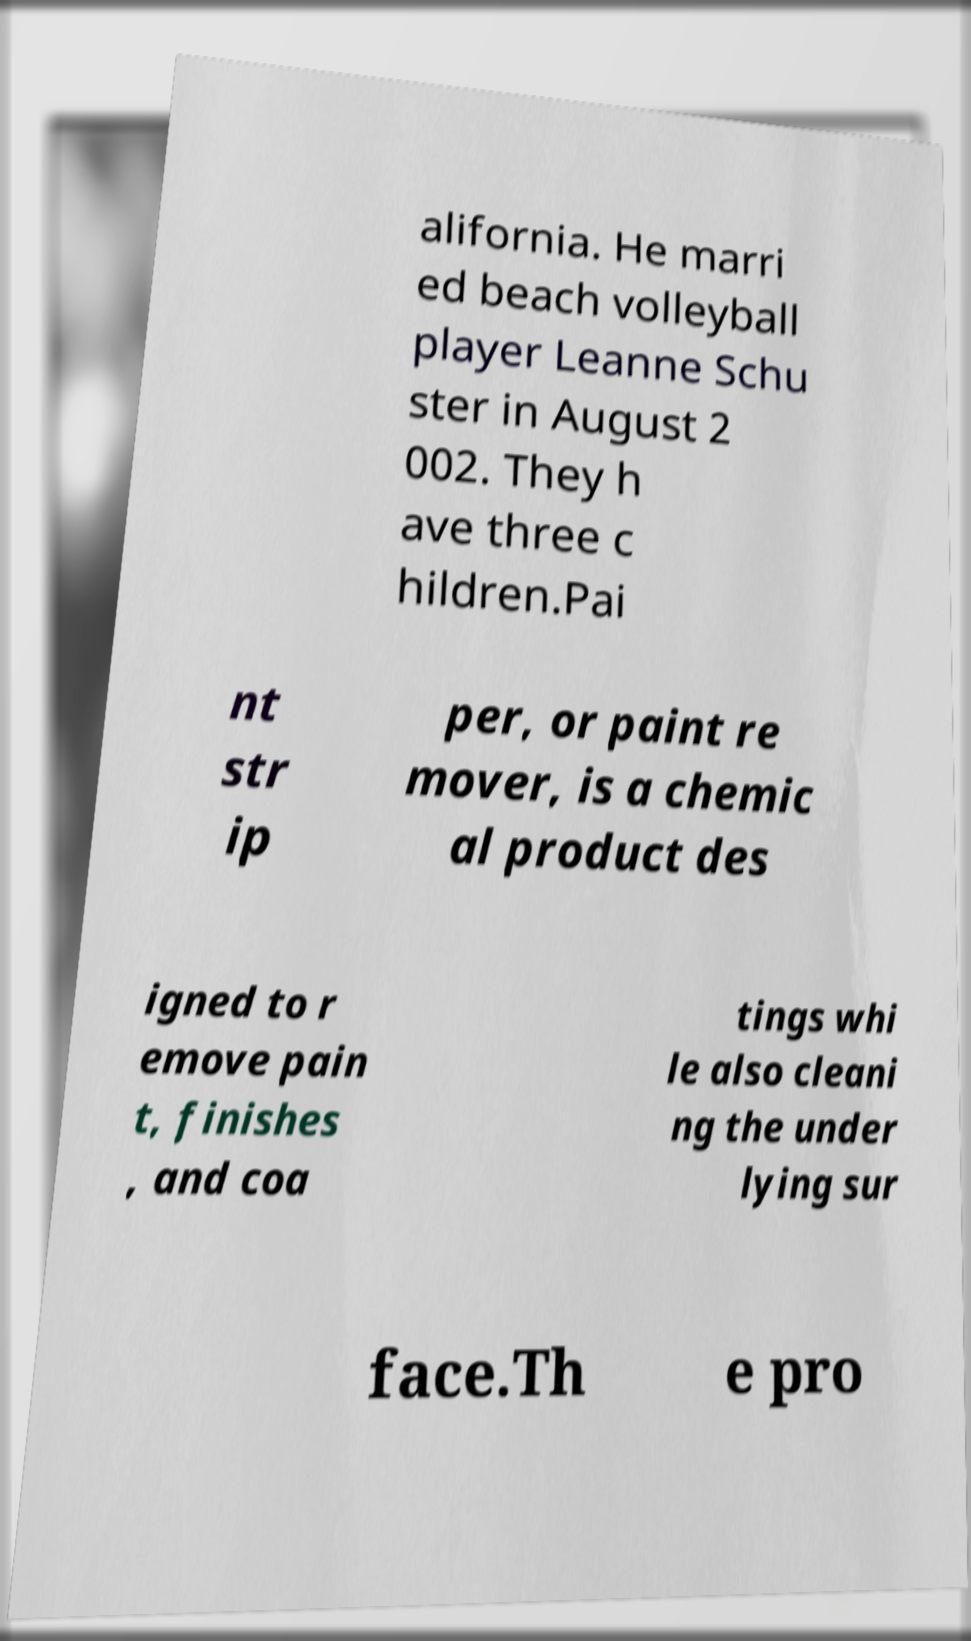For documentation purposes, I need the text within this image transcribed. Could you provide that? alifornia. He marri ed beach volleyball player Leanne Schu ster in August 2 002. They h ave three c hildren.Pai nt str ip per, or paint re mover, is a chemic al product des igned to r emove pain t, finishes , and coa tings whi le also cleani ng the under lying sur face.Th e pro 